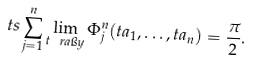<formula> <loc_0><loc_0><loc_500><loc_500>\ t s \sum _ { j = 1 } ^ { n } \lim _ { t \ r a \i y } \Phi ^ { n } _ { j } ( t a _ { 1 } , \dots , t a _ { n } ) = \frac { \pi } { 2 } .</formula> 